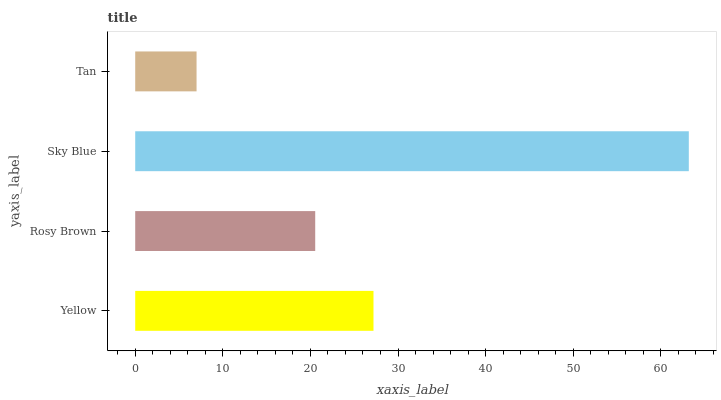Is Tan the minimum?
Answer yes or no. Yes. Is Sky Blue the maximum?
Answer yes or no. Yes. Is Rosy Brown the minimum?
Answer yes or no. No. Is Rosy Brown the maximum?
Answer yes or no. No. Is Yellow greater than Rosy Brown?
Answer yes or no. Yes. Is Rosy Brown less than Yellow?
Answer yes or no. Yes. Is Rosy Brown greater than Yellow?
Answer yes or no. No. Is Yellow less than Rosy Brown?
Answer yes or no. No. Is Yellow the high median?
Answer yes or no. Yes. Is Rosy Brown the low median?
Answer yes or no. Yes. Is Tan the high median?
Answer yes or no. No. Is Tan the low median?
Answer yes or no. No. 